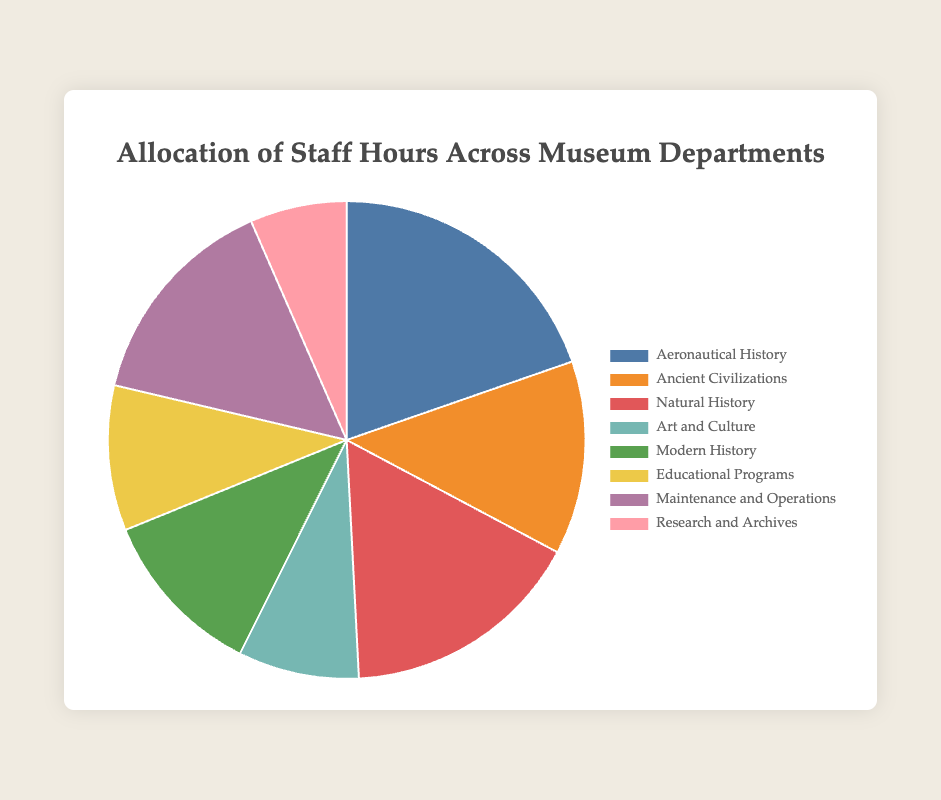What percentage of the total staff hours is allocated to the Aeronautical History department? From the figure, Aeronautical History has 1200 staff hours. To find the percentage, divide 1200 by the total staff hours (which is 1200 + 800 + 1000 + 500 + 700 + 600 + 900 + 400 = 6100) and then multiply by 100. So, (1200 / 6100) * 100 ≈ 19.67%
Answer: Approximately 19.67% Which department has the smallest allocation of staff hours and how many hours is it allocated? From the pie chart, Research and Archives has the smallest portion of the pie, indicating it has the least hours. The figure shows that Research and Archives is allocated 400 hours.
Answer: Research and Archives, 400 hours Sum the staff hours allocated to Educational Programs and Maintenance and Operations. How does this total compare to the hours allocated to Ancient Civilizations and Modern History combined? Educational Programs and Maintenance and Operations together have 600 + 900 = 1500 hours. Ancient Civilizations and Modern History together have 800 + 700 = 1500 hours. Both sums are equal.
Answer: They are equal, 1500 hours each What is the color representation for Natural History in the pie chart? From the figure, the Natural History section of the pie chart is represented using the color that looks like a mix of green and yellowish tone.
Answer: A greenish yellow tone Which department's allocation is closer to 700 staff hours: Art and Culture or Modern History? From the pie chart, Art and Culture has 500 hours, while Modern History has 700 hours. Modern History exactly matches 700 hours making it the closer of the two.
Answer: Modern History Calculate the average staff hours allocated across all departments. To find the average, sum all the staff hours (1200 + 800 + 1000 + 500 + 700 + 600 + 900 + 400 = 6100) and divide by the number of departments, which is 8. So, 6100 / 8 = 762.5 hours.
Answer: 762.5 hours Which three departments have the highest allocations of staff hours? By looking at the proportions in the pie chart, Aeronautical History (1200 hours), Natural History (1000 hours), and Maintenance and Operations (900 hours) have the highest allocations.
Answer: Aeronautical History, Natural History, Maintenance and Operations How does the allocation to Aeronautical History compare to half of the total staff hours available? Half of the total staff hours is 6100 / 2 = 3050 hours. Aeronautical History has 1200 hours, which is less than 3050 hours.
Answer: Less than half 